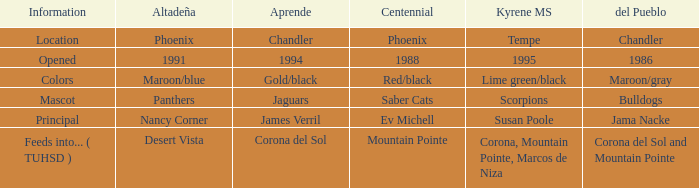Which Centennial has a del Pueblo of 1986? 1988.0. 